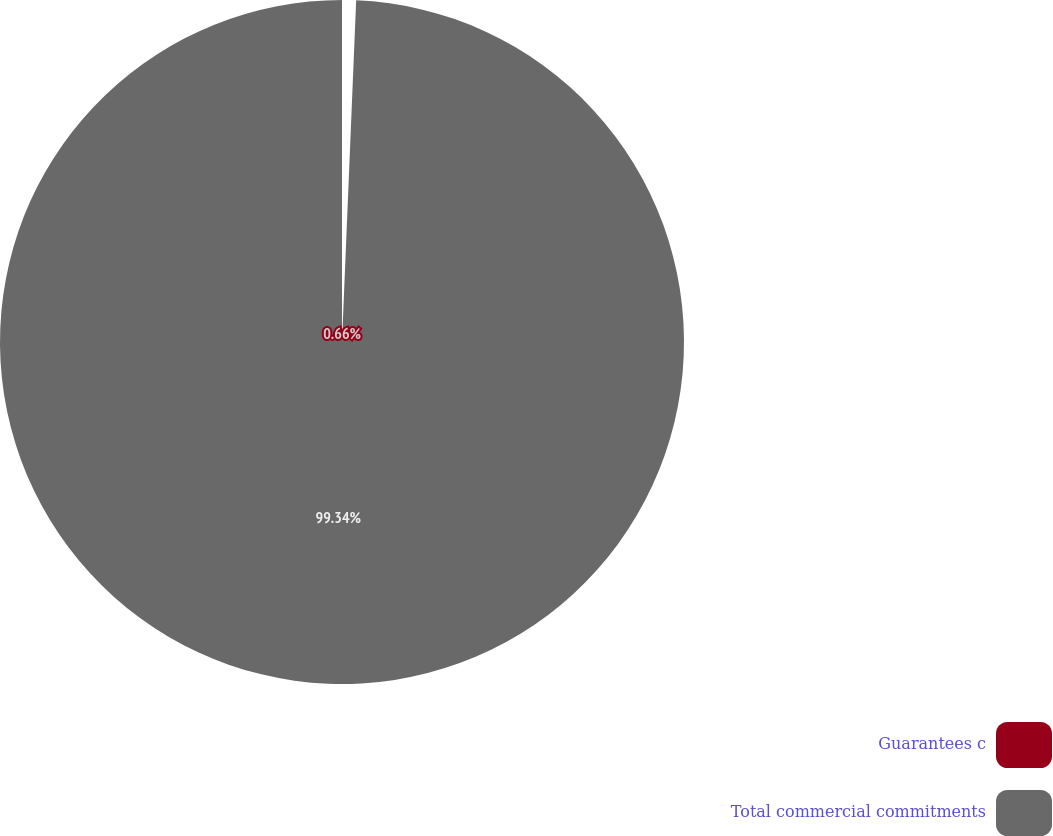Convert chart to OTSL. <chart><loc_0><loc_0><loc_500><loc_500><pie_chart><fcel>Guarantees c<fcel>Total commercial commitments<nl><fcel>0.66%<fcel>99.34%<nl></chart> 